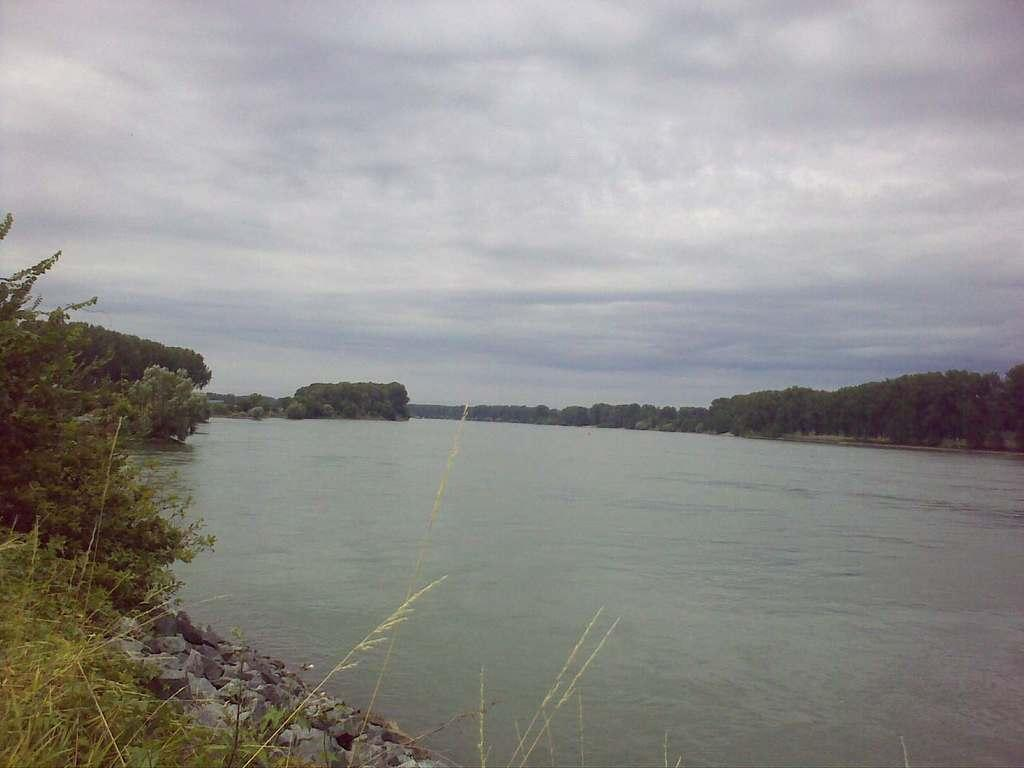What is the main feature of the picture? There is a lake in the picture. What can be seen in the bottom left of the picture? There are many stones in the bottom left of the picture. What is visible in the background of the picture? There are trees, plants, and grass in the background of the picture. What is visible at the top of the picture? The sky is visible at the top of the picture. What can be seen in the sky? Clouds are present in the sky. What type of ink is being used to draw the attention of the lake in the picture? There is no ink or drawing in the picture; it is a photograph of a lake with stones, trees, plants, grass, sky, and clouds. 